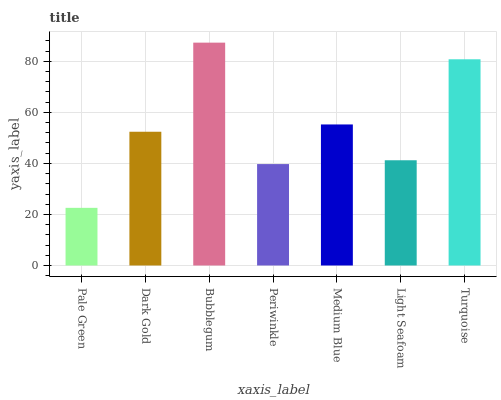Is Pale Green the minimum?
Answer yes or no. Yes. Is Bubblegum the maximum?
Answer yes or no. Yes. Is Dark Gold the minimum?
Answer yes or no. No. Is Dark Gold the maximum?
Answer yes or no. No. Is Dark Gold greater than Pale Green?
Answer yes or no. Yes. Is Pale Green less than Dark Gold?
Answer yes or no. Yes. Is Pale Green greater than Dark Gold?
Answer yes or no. No. Is Dark Gold less than Pale Green?
Answer yes or no. No. Is Dark Gold the high median?
Answer yes or no. Yes. Is Dark Gold the low median?
Answer yes or no. Yes. Is Medium Blue the high median?
Answer yes or no. No. Is Bubblegum the low median?
Answer yes or no. No. 